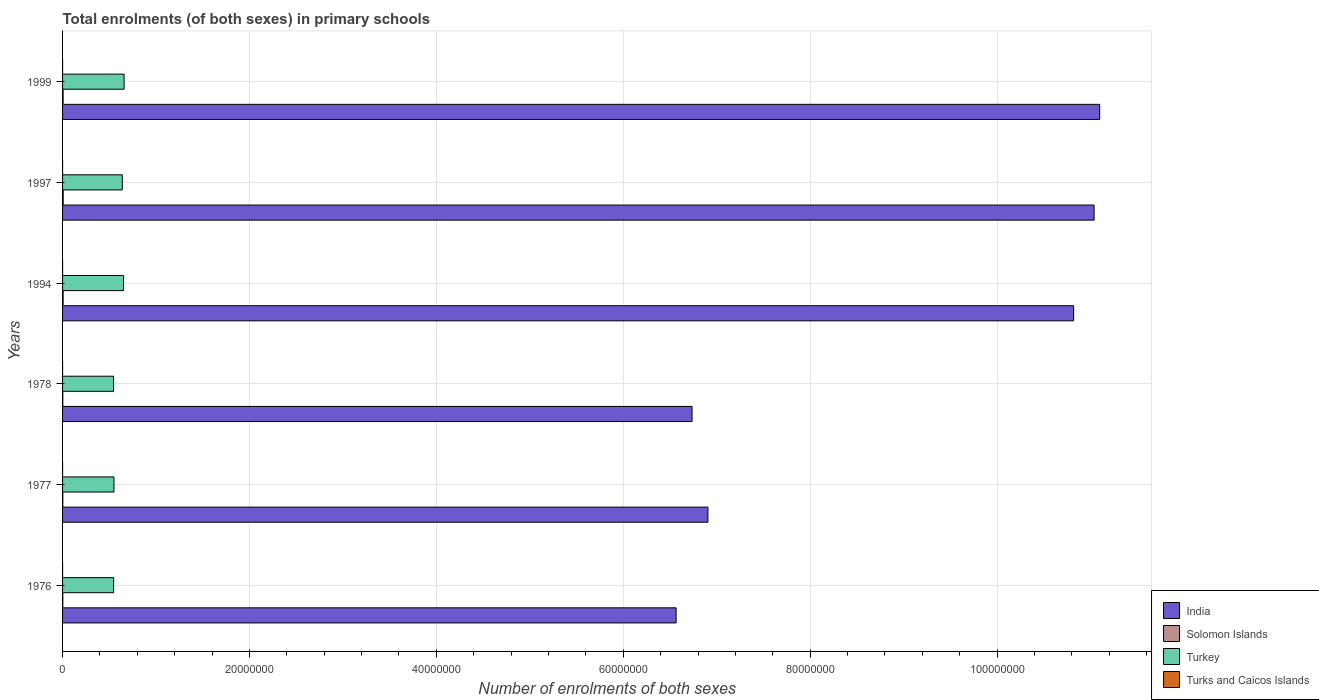How many groups of bars are there?
Offer a terse response. 6. Are the number of bars per tick equal to the number of legend labels?
Your answer should be very brief. Yes. What is the label of the 3rd group of bars from the top?
Your answer should be compact. 1994. In how many cases, is the number of bars for a given year not equal to the number of legend labels?
Provide a short and direct response. 0. What is the number of enrolments in primary schools in Turkey in 1999?
Offer a very short reply. 6.58e+06. Across all years, what is the maximum number of enrolments in primary schools in India?
Offer a terse response. 1.11e+08. Across all years, what is the minimum number of enrolments in primary schools in Turks and Caicos Islands?
Your answer should be very brief. 1573. In which year was the number of enrolments in primary schools in Turks and Caicos Islands minimum?
Provide a short and direct response. 1997. What is the total number of enrolments in primary schools in Turkey in the graph?
Ensure brevity in your answer.  3.59e+07. What is the difference between the number of enrolments in primary schools in Turks and Caicos Islands in 1978 and that in 1997?
Ensure brevity in your answer.  119. What is the difference between the number of enrolments in primary schools in Turkey in 1977 and the number of enrolments in primary schools in Solomon Islands in 1999?
Offer a terse response. 5.44e+06. What is the average number of enrolments in primary schools in Turks and Caicos Islands per year?
Provide a short and direct response. 1733.5. In the year 1978, what is the difference between the number of enrolments in primary schools in Turkey and number of enrolments in primary schools in Solomon Islands?
Give a very brief answer. 5.43e+06. What is the ratio of the number of enrolments in primary schools in Turks and Caicos Islands in 1976 to that in 1999?
Offer a terse response. 0.97. Is the number of enrolments in primary schools in Turks and Caicos Islands in 1994 less than that in 1997?
Offer a terse response. No. Is the difference between the number of enrolments in primary schools in Turkey in 1976 and 1977 greater than the difference between the number of enrolments in primary schools in Solomon Islands in 1976 and 1977?
Provide a short and direct response. No. What is the difference between the highest and the second highest number of enrolments in primary schools in Turks and Caicos Islands?
Offer a very short reply. 22. What is the difference between the highest and the lowest number of enrolments in primary schools in Solomon Islands?
Your answer should be compact. 4.04e+04. In how many years, is the number of enrolments in primary schools in Turkey greater than the average number of enrolments in primary schools in Turkey taken over all years?
Make the answer very short. 3. What does the 1st bar from the top in 1997 represents?
Keep it short and to the point. Turks and Caicos Islands. Is it the case that in every year, the sum of the number of enrolments in primary schools in Turkey and number of enrolments in primary schools in India is greater than the number of enrolments in primary schools in Solomon Islands?
Offer a terse response. Yes. How many bars are there?
Your answer should be compact. 24. Are all the bars in the graph horizontal?
Your answer should be compact. Yes. What is the title of the graph?
Give a very brief answer. Total enrolments (of both sexes) in primary schools. What is the label or title of the X-axis?
Your response must be concise. Number of enrolments of both sexes. What is the label or title of the Y-axis?
Ensure brevity in your answer.  Years. What is the Number of enrolments of both sexes of India in 1976?
Your response must be concise. 6.57e+07. What is the Number of enrolments of both sexes of Solomon Islands in 1976?
Offer a terse response. 2.70e+04. What is the Number of enrolments of both sexes in Turkey in 1976?
Make the answer very short. 5.46e+06. What is the Number of enrolments of both sexes in Turks and Caicos Islands in 1976?
Your response must be concise. 1764. What is the Number of enrolments of both sexes in India in 1977?
Offer a very short reply. 6.91e+07. What is the Number of enrolments of both sexes in Solomon Islands in 1977?
Your response must be concise. 2.64e+04. What is the Number of enrolments of both sexes in Turkey in 1977?
Keep it short and to the point. 5.50e+06. What is the Number of enrolments of both sexes in Turks and Caicos Islands in 1977?
Offer a terse response. 1800. What is the Number of enrolments of both sexes in India in 1978?
Make the answer very short. 6.74e+07. What is the Number of enrolments of both sexes in Solomon Islands in 1978?
Offer a terse response. 2.67e+04. What is the Number of enrolments of both sexes in Turkey in 1978?
Offer a very short reply. 5.45e+06. What is the Number of enrolments of both sexes of Turks and Caicos Islands in 1978?
Keep it short and to the point. 1692. What is the Number of enrolments of both sexes of India in 1994?
Give a very brief answer. 1.08e+08. What is the Number of enrolments of both sexes of Solomon Islands in 1994?
Your answer should be compact. 6.05e+04. What is the Number of enrolments of both sexes in Turkey in 1994?
Your answer should be very brief. 6.53e+06. What is the Number of enrolments of both sexes in Turks and Caicos Islands in 1994?
Give a very brief answer. 1750. What is the Number of enrolments of both sexes of India in 1997?
Make the answer very short. 1.10e+08. What is the Number of enrolments of both sexes of Solomon Islands in 1997?
Give a very brief answer. 6.68e+04. What is the Number of enrolments of both sexes of Turkey in 1997?
Provide a short and direct response. 6.39e+06. What is the Number of enrolments of both sexes of Turks and Caicos Islands in 1997?
Offer a terse response. 1573. What is the Number of enrolments of both sexes in India in 1999?
Ensure brevity in your answer.  1.11e+08. What is the Number of enrolments of both sexes in Solomon Islands in 1999?
Offer a terse response. 5.80e+04. What is the Number of enrolments of both sexes of Turkey in 1999?
Provide a short and direct response. 6.58e+06. What is the Number of enrolments of both sexes of Turks and Caicos Islands in 1999?
Ensure brevity in your answer.  1822. Across all years, what is the maximum Number of enrolments of both sexes of India?
Provide a short and direct response. 1.11e+08. Across all years, what is the maximum Number of enrolments of both sexes of Solomon Islands?
Your answer should be very brief. 6.68e+04. Across all years, what is the maximum Number of enrolments of both sexes of Turkey?
Keep it short and to the point. 6.58e+06. Across all years, what is the maximum Number of enrolments of both sexes in Turks and Caicos Islands?
Give a very brief answer. 1822. Across all years, what is the minimum Number of enrolments of both sexes in India?
Your answer should be compact. 6.57e+07. Across all years, what is the minimum Number of enrolments of both sexes of Solomon Islands?
Provide a short and direct response. 2.64e+04. Across all years, what is the minimum Number of enrolments of both sexes in Turkey?
Provide a short and direct response. 5.45e+06. Across all years, what is the minimum Number of enrolments of both sexes of Turks and Caicos Islands?
Keep it short and to the point. 1573. What is the total Number of enrolments of both sexes in India in the graph?
Provide a succinct answer. 5.32e+08. What is the total Number of enrolments of both sexes in Solomon Islands in the graph?
Your response must be concise. 2.66e+05. What is the total Number of enrolments of both sexes in Turkey in the graph?
Your response must be concise. 3.59e+07. What is the total Number of enrolments of both sexes in Turks and Caicos Islands in the graph?
Give a very brief answer. 1.04e+04. What is the difference between the Number of enrolments of both sexes in India in 1976 and that in 1977?
Provide a succinct answer. -3.40e+06. What is the difference between the Number of enrolments of both sexes of Solomon Islands in 1976 and that in 1977?
Offer a terse response. 631. What is the difference between the Number of enrolments of both sexes of Turkey in 1976 and that in 1977?
Ensure brevity in your answer.  -3.58e+04. What is the difference between the Number of enrolments of both sexes in Turks and Caicos Islands in 1976 and that in 1977?
Make the answer very short. -36. What is the difference between the Number of enrolments of both sexes of India in 1976 and that in 1978?
Make the answer very short. -1.70e+06. What is the difference between the Number of enrolments of both sexes in Solomon Islands in 1976 and that in 1978?
Give a very brief answer. 272. What is the difference between the Number of enrolments of both sexes in Turkey in 1976 and that in 1978?
Make the answer very short. 9328. What is the difference between the Number of enrolments of both sexes of Turks and Caicos Islands in 1976 and that in 1978?
Offer a terse response. 72. What is the difference between the Number of enrolments of both sexes in India in 1976 and that in 1994?
Keep it short and to the point. -4.25e+07. What is the difference between the Number of enrolments of both sexes in Solomon Islands in 1976 and that in 1994?
Make the answer very short. -3.35e+04. What is the difference between the Number of enrolments of both sexes in Turkey in 1976 and that in 1994?
Offer a very short reply. -1.06e+06. What is the difference between the Number of enrolments of both sexes in Turks and Caicos Islands in 1976 and that in 1994?
Your answer should be very brief. 14. What is the difference between the Number of enrolments of both sexes in India in 1976 and that in 1997?
Offer a very short reply. -4.47e+07. What is the difference between the Number of enrolments of both sexes of Solomon Islands in 1976 and that in 1997?
Your answer should be compact. -3.98e+04. What is the difference between the Number of enrolments of both sexes in Turkey in 1976 and that in 1997?
Make the answer very short. -9.25e+05. What is the difference between the Number of enrolments of both sexes of Turks and Caicos Islands in 1976 and that in 1997?
Your response must be concise. 191. What is the difference between the Number of enrolments of both sexes of India in 1976 and that in 1999?
Give a very brief answer. -4.53e+07. What is the difference between the Number of enrolments of both sexes of Solomon Islands in 1976 and that in 1999?
Your answer should be very brief. -3.10e+04. What is the difference between the Number of enrolments of both sexes in Turkey in 1976 and that in 1999?
Keep it short and to the point. -1.12e+06. What is the difference between the Number of enrolments of both sexes of Turks and Caicos Islands in 1976 and that in 1999?
Provide a succinct answer. -58. What is the difference between the Number of enrolments of both sexes in India in 1977 and that in 1978?
Your response must be concise. 1.70e+06. What is the difference between the Number of enrolments of both sexes of Solomon Islands in 1977 and that in 1978?
Provide a succinct answer. -359. What is the difference between the Number of enrolments of both sexes in Turkey in 1977 and that in 1978?
Your answer should be very brief. 4.51e+04. What is the difference between the Number of enrolments of both sexes in Turks and Caicos Islands in 1977 and that in 1978?
Make the answer very short. 108. What is the difference between the Number of enrolments of both sexes of India in 1977 and that in 1994?
Offer a terse response. -3.91e+07. What is the difference between the Number of enrolments of both sexes in Solomon Islands in 1977 and that in 1994?
Give a very brief answer. -3.41e+04. What is the difference between the Number of enrolments of both sexes of Turkey in 1977 and that in 1994?
Your answer should be compact. -1.03e+06. What is the difference between the Number of enrolments of both sexes of Turks and Caicos Islands in 1977 and that in 1994?
Provide a short and direct response. 50. What is the difference between the Number of enrolments of both sexes in India in 1977 and that in 1997?
Keep it short and to the point. -4.13e+07. What is the difference between the Number of enrolments of both sexes in Solomon Islands in 1977 and that in 1997?
Offer a terse response. -4.04e+04. What is the difference between the Number of enrolments of both sexes in Turkey in 1977 and that in 1997?
Keep it short and to the point. -8.90e+05. What is the difference between the Number of enrolments of both sexes of Turks and Caicos Islands in 1977 and that in 1997?
Give a very brief answer. 227. What is the difference between the Number of enrolments of both sexes in India in 1977 and that in 1999?
Keep it short and to the point. -4.19e+07. What is the difference between the Number of enrolments of both sexes of Solomon Islands in 1977 and that in 1999?
Offer a terse response. -3.16e+04. What is the difference between the Number of enrolments of both sexes in Turkey in 1977 and that in 1999?
Your answer should be compact. -1.08e+06. What is the difference between the Number of enrolments of both sexes in India in 1978 and that in 1994?
Keep it short and to the point. -4.08e+07. What is the difference between the Number of enrolments of both sexes in Solomon Islands in 1978 and that in 1994?
Your answer should be compact. -3.37e+04. What is the difference between the Number of enrolments of both sexes in Turkey in 1978 and that in 1994?
Ensure brevity in your answer.  -1.07e+06. What is the difference between the Number of enrolments of both sexes of Turks and Caicos Islands in 1978 and that in 1994?
Offer a terse response. -58. What is the difference between the Number of enrolments of both sexes in India in 1978 and that in 1997?
Provide a succinct answer. -4.30e+07. What is the difference between the Number of enrolments of both sexes in Solomon Islands in 1978 and that in 1997?
Provide a short and direct response. -4.01e+04. What is the difference between the Number of enrolments of both sexes of Turkey in 1978 and that in 1997?
Your answer should be very brief. -9.35e+05. What is the difference between the Number of enrolments of both sexes of Turks and Caicos Islands in 1978 and that in 1997?
Give a very brief answer. 119. What is the difference between the Number of enrolments of both sexes in India in 1978 and that in 1999?
Your response must be concise. -4.36e+07. What is the difference between the Number of enrolments of both sexes in Solomon Islands in 1978 and that in 1999?
Provide a short and direct response. -3.13e+04. What is the difference between the Number of enrolments of both sexes of Turkey in 1978 and that in 1999?
Offer a terse response. -1.13e+06. What is the difference between the Number of enrolments of both sexes of Turks and Caicos Islands in 1978 and that in 1999?
Make the answer very short. -130. What is the difference between the Number of enrolments of both sexes in India in 1994 and that in 1997?
Ensure brevity in your answer.  -2.19e+06. What is the difference between the Number of enrolments of both sexes of Solomon Islands in 1994 and that in 1997?
Offer a terse response. -6347. What is the difference between the Number of enrolments of both sexes in Turkey in 1994 and that in 1997?
Ensure brevity in your answer.  1.37e+05. What is the difference between the Number of enrolments of both sexes of Turks and Caicos Islands in 1994 and that in 1997?
Ensure brevity in your answer.  177. What is the difference between the Number of enrolments of both sexes in India in 1994 and that in 1999?
Provide a succinct answer. -2.79e+06. What is the difference between the Number of enrolments of both sexes in Solomon Islands in 1994 and that in 1999?
Your response must be concise. 2477. What is the difference between the Number of enrolments of both sexes in Turkey in 1994 and that in 1999?
Your answer should be compact. -5.69e+04. What is the difference between the Number of enrolments of both sexes in Turks and Caicos Islands in 1994 and that in 1999?
Make the answer very short. -72. What is the difference between the Number of enrolments of both sexes of India in 1997 and that in 1999?
Ensure brevity in your answer.  -5.95e+05. What is the difference between the Number of enrolments of both sexes in Solomon Islands in 1997 and that in 1999?
Offer a terse response. 8824. What is the difference between the Number of enrolments of both sexes of Turkey in 1997 and that in 1999?
Provide a succinct answer. -1.94e+05. What is the difference between the Number of enrolments of both sexes of Turks and Caicos Islands in 1997 and that in 1999?
Ensure brevity in your answer.  -249. What is the difference between the Number of enrolments of both sexes of India in 1976 and the Number of enrolments of both sexes of Solomon Islands in 1977?
Give a very brief answer. 6.56e+07. What is the difference between the Number of enrolments of both sexes in India in 1976 and the Number of enrolments of both sexes in Turkey in 1977?
Your response must be concise. 6.02e+07. What is the difference between the Number of enrolments of both sexes of India in 1976 and the Number of enrolments of both sexes of Turks and Caicos Islands in 1977?
Provide a short and direct response. 6.57e+07. What is the difference between the Number of enrolments of both sexes in Solomon Islands in 1976 and the Number of enrolments of both sexes in Turkey in 1977?
Your response must be concise. -5.47e+06. What is the difference between the Number of enrolments of both sexes in Solomon Islands in 1976 and the Number of enrolments of both sexes in Turks and Caicos Islands in 1977?
Keep it short and to the point. 2.52e+04. What is the difference between the Number of enrolments of both sexes in Turkey in 1976 and the Number of enrolments of both sexes in Turks and Caicos Islands in 1977?
Your response must be concise. 5.46e+06. What is the difference between the Number of enrolments of both sexes in India in 1976 and the Number of enrolments of both sexes in Solomon Islands in 1978?
Offer a very short reply. 6.56e+07. What is the difference between the Number of enrolments of both sexes in India in 1976 and the Number of enrolments of both sexes in Turkey in 1978?
Give a very brief answer. 6.02e+07. What is the difference between the Number of enrolments of both sexes in India in 1976 and the Number of enrolments of both sexes in Turks and Caicos Islands in 1978?
Provide a succinct answer. 6.57e+07. What is the difference between the Number of enrolments of both sexes of Solomon Islands in 1976 and the Number of enrolments of both sexes of Turkey in 1978?
Offer a terse response. -5.43e+06. What is the difference between the Number of enrolments of both sexes of Solomon Islands in 1976 and the Number of enrolments of both sexes of Turks and Caicos Islands in 1978?
Provide a succinct answer. 2.53e+04. What is the difference between the Number of enrolments of both sexes in Turkey in 1976 and the Number of enrolments of both sexes in Turks and Caicos Islands in 1978?
Your answer should be compact. 5.46e+06. What is the difference between the Number of enrolments of both sexes of India in 1976 and the Number of enrolments of both sexes of Solomon Islands in 1994?
Your response must be concise. 6.56e+07. What is the difference between the Number of enrolments of both sexes in India in 1976 and the Number of enrolments of both sexes in Turkey in 1994?
Offer a very short reply. 5.91e+07. What is the difference between the Number of enrolments of both sexes of India in 1976 and the Number of enrolments of both sexes of Turks and Caicos Islands in 1994?
Offer a terse response. 6.57e+07. What is the difference between the Number of enrolments of both sexes in Solomon Islands in 1976 and the Number of enrolments of both sexes in Turkey in 1994?
Keep it short and to the point. -6.50e+06. What is the difference between the Number of enrolments of both sexes of Solomon Islands in 1976 and the Number of enrolments of both sexes of Turks and Caicos Islands in 1994?
Make the answer very short. 2.53e+04. What is the difference between the Number of enrolments of both sexes of Turkey in 1976 and the Number of enrolments of both sexes of Turks and Caicos Islands in 1994?
Your response must be concise. 5.46e+06. What is the difference between the Number of enrolments of both sexes in India in 1976 and the Number of enrolments of both sexes in Solomon Islands in 1997?
Offer a terse response. 6.56e+07. What is the difference between the Number of enrolments of both sexes in India in 1976 and the Number of enrolments of both sexes in Turkey in 1997?
Provide a succinct answer. 5.93e+07. What is the difference between the Number of enrolments of both sexes in India in 1976 and the Number of enrolments of both sexes in Turks and Caicos Islands in 1997?
Give a very brief answer. 6.57e+07. What is the difference between the Number of enrolments of both sexes of Solomon Islands in 1976 and the Number of enrolments of both sexes of Turkey in 1997?
Your answer should be very brief. -6.36e+06. What is the difference between the Number of enrolments of both sexes of Solomon Islands in 1976 and the Number of enrolments of both sexes of Turks and Caicos Islands in 1997?
Give a very brief answer. 2.54e+04. What is the difference between the Number of enrolments of both sexes in Turkey in 1976 and the Number of enrolments of both sexes in Turks and Caicos Islands in 1997?
Your response must be concise. 5.46e+06. What is the difference between the Number of enrolments of both sexes of India in 1976 and the Number of enrolments of both sexes of Solomon Islands in 1999?
Keep it short and to the point. 6.56e+07. What is the difference between the Number of enrolments of both sexes in India in 1976 and the Number of enrolments of both sexes in Turkey in 1999?
Your answer should be compact. 5.91e+07. What is the difference between the Number of enrolments of both sexes in India in 1976 and the Number of enrolments of both sexes in Turks and Caicos Islands in 1999?
Provide a short and direct response. 6.57e+07. What is the difference between the Number of enrolments of both sexes in Solomon Islands in 1976 and the Number of enrolments of both sexes in Turkey in 1999?
Give a very brief answer. -6.56e+06. What is the difference between the Number of enrolments of both sexes in Solomon Islands in 1976 and the Number of enrolments of both sexes in Turks and Caicos Islands in 1999?
Provide a succinct answer. 2.52e+04. What is the difference between the Number of enrolments of both sexes in Turkey in 1976 and the Number of enrolments of both sexes in Turks and Caicos Islands in 1999?
Keep it short and to the point. 5.46e+06. What is the difference between the Number of enrolments of both sexes in India in 1977 and the Number of enrolments of both sexes in Solomon Islands in 1978?
Make the answer very short. 6.90e+07. What is the difference between the Number of enrolments of both sexes of India in 1977 and the Number of enrolments of both sexes of Turkey in 1978?
Your response must be concise. 6.36e+07. What is the difference between the Number of enrolments of both sexes in India in 1977 and the Number of enrolments of both sexes in Turks and Caicos Islands in 1978?
Your response must be concise. 6.91e+07. What is the difference between the Number of enrolments of both sexes in Solomon Islands in 1977 and the Number of enrolments of both sexes in Turkey in 1978?
Your answer should be very brief. -5.43e+06. What is the difference between the Number of enrolments of both sexes of Solomon Islands in 1977 and the Number of enrolments of both sexes of Turks and Caicos Islands in 1978?
Your answer should be very brief. 2.47e+04. What is the difference between the Number of enrolments of both sexes of Turkey in 1977 and the Number of enrolments of both sexes of Turks and Caicos Islands in 1978?
Give a very brief answer. 5.50e+06. What is the difference between the Number of enrolments of both sexes of India in 1977 and the Number of enrolments of both sexes of Solomon Islands in 1994?
Your response must be concise. 6.90e+07. What is the difference between the Number of enrolments of both sexes of India in 1977 and the Number of enrolments of both sexes of Turkey in 1994?
Your answer should be compact. 6.25e+07. What is the difference between the Number of enrolments of both sexes of India in 1977 and the Number of enrolments of both sexes of Turks and Caicos Islands in 1994?
Keep it short and to the point. 6.91e+07. What is the difference between the Number of enrolments of both sexes of Solomon Islands in 1977 and the Number of enrolments of both sexes of Turkey in 1994?
Your answer should be compact. -6.50e+06. What is the difference between the Number of enrolments of both sexes of Solomon Islands in 1977 and the Number of enrolments of both sexes of Turks and Caicos Islands in 1994?
Provide a short and direct response. 2.46e+04. What is the difference between the Number of enrolments of both sexes of Turkey in 1977 and the Number of enrolments of both sexes of Turks and Caicos Islands in 1994?
Offer a very short reply. 5.50e+06. What is the difference between the Number of enrolments of both sexes in India in 1977 and the Number of enrolments of both sexes in Solomon Islands in 1997?
Provide a succinct answer. 6.90e+07. What is the difference between the Number of enrolments of both sexes of India in 1977 and the Number of enrolments of both sexes of Turkey in 1997?
Offer a terse response. 6.27e+07. What is the difference between the Number of enrolments of both sexes in India in 1977 and the Number of enrolments of both sexes in Turks and Caicos Islands in 1997?
Provide a succinct answer. 6.91e+07. What is the difference between the Number of enrolments of both sexes of Solomon Islands in 1977 and the Number of enrolments of both sexes of Turkey in 1997?
Your answer should be very brief. -6.36e+06. What is the difference between the Number of enrolments of both sexes in Solomon Islands in 1977 and the Number of enrolments of both sexes in Turks and Caicos Islands in 1997?
Provide a short and direct response. 2.48e+04. What is the difference between the Number of enrolments of both sexes in Turkey in 1977 and the Number of enrolments of both sexes in Turks and Caicos Islands in 1997?
Keep it short and to the point. 5.50e+06. What is the difference between the Number of enrolments of both sexes of India in 1977 and the Number of enrolments of both sexes of Solomon Islands in 1999?
Your answer should be compact. 6.90e+07. What is the difference between the Number of enrolments of both sexes of India in 1977 and the Number of enrolments of both sexes of Turkey in 1999?
Ensure brevity in your answer.  6.25e+07. What is the difference between the Number of enrolments of both sexes in India in 1977 and the Number of enrolments of both sexes in Turks and Caicos Islands in 1999?
Make the answer very short. 6.91e+07. What is the difference between the Number of enrolments of both sexes in Solomon Islands in 1977 and the Number of enrolments of both sexes in Turkey in 1999?
Ensure brevity in your answer.  -6.56e+06. What is the difference between the Number of enrolments of both sexes of Solomon Islands in 1977 and the Number of enrolments of both sexes of Turks and Caicos Islands in 1999?
Provide a succinct answer. 2.46e+04. What is the difference between the Number of enrolments of both sexes of Turkey in 1977 and the Number of enrolments of both sexes of Turks and Caicos Islands in 1999?
Keep it short and to the point. 5.50e+06. What is the difference between the Number of enrolments of both sexes of India in 1978 and the Number of enrolments of both sexes of Solomon Islands in 1994?
Your answer should be very brief. 6.73e+07. What is the difference between the Number of enrolments of both sexes of India in 1978 and the Number of enrolments of both sexes of Turkey in 1994?
Your answer should be compact. 6.08e+07. What is the difference between the Number of enrolments of both sexes in India in 1978 and the Number of enrolments of both sexes in Turks and Caicos Islands in 1994?
Provide a succinct answer. 6.74e+07. What is the difference between the Number of enrolments of both sexes in Solomon Islands in 1978 and the Number of enrolments of both sexes in Turkey in 1994?
Offer a very short reply. -6.50e+06. What is the difference between the Number of enrolments of both sexes in Solomon Islands in 1978 and the Number of enrolments of both sexes in Turks and Caicos Islands in 1994?
Provide a short and direct response. 2.50e+04. What is the difference between the Number of enrolments of both sexes in Turkey in 1978 and the Number of enrolments of both sexes in Turks and Caicos Islands in 1994?
Offer a terse response. 5.45e+06. What is the difference between the Number of enrolments of both sexes of India in 1978 and the Number of enrolments of both sexes of Solomon Islands in 1997?
Your answer should be compact. 6.73e+07. What is the difference between the Number of enrolments of both sexes in India in 1978 and the Number of enrolments of both sexes in Turkey in 1997?
Ensure brevity in your answer.  6.10e+07. What is the difference between the Number of enrolments of both sexes in India in 1978 and the Number of enrolments of both sexes in Turks and Caicos Islands in 1997?
Your answer should be compact. 6.74e+07. What is the difference between the Number of enrolments of both sexes in Solomon Islands in 1978 and the Number of enrolments of both sexes in Turkey in 1997?
Make the answer very short. -6.36e+06. What is the difference between the Number of enrolments of both sexes of Solomon Islands in 1978 and the Number of enrolments of both sexes of Turks and Caicos Islands in 1997?
Your answer should be compact. 2.52e+04. What is the difference between the Number of enrolments of both sexes in Turkey in 1978 and the Number of enrolments of both sexes in Turks and Caicos Islands in 1997?
Give a very brief answer. 5.45e+06. What is the difference between the Number of enrolments of both sexes of India in 1978 and the Number of enrolments of both sexes of Solomon Islands in 1999?
Offer a terse response. 6.73e+07. What is the difference between the Number of enrolments of both sexes of India in 1978 and the Number of enrolments of both sexes of Turkey in 1999?
Make the answer very short. 6.08e+07. What is the difference between the Number of enrolments of both sexes of India in 1978 and the Number of enrolments of both sexes of Turks and Caicos Islands in 1999?
Your answer should be very brief. 6.74e+07. What is the difference between the Number of enrolments of both sexes in Solomon Islands in 1978 and the Number of enrolments of both sexes in Turkey in 1999?
Give a very brief answer. -6.56e+06. What is the difference between the Number of enrolments of both sexes in Solomon Islands in 1978 and the Number of enrolments of both sexes in Turks and Caicos Islands in 1999?
Your answer should be very brief. 2.49e+04. What is the difference between the Number of enrolments of both sexes of Turkey in 1978 and the Number of enrolments of both sexes of Turks and Caicos Islands in 1999?
Your response must be concise. 5.45e+06. What is the difference between the Number of enrolments of both sexes of India in 1994 and the Number of enrolments of both sexes of Solomon Islands in 1997?
Offer a very short reply. 1.08e+08. What is the difference between the Number of enrolments of both sexes of India in 1994 and the Number of enrolments of both sexes of Turkey in 1997?
Provide a succinct answer. 1.02e+08. What is the difference between the Number of enrolments of both sexes of India in 1994 and the Number of enrolments of both sexes of Turks and Caicos Islands in 1997?
Make the answer very short. 1.08e+08. What is the difference between the Number of enrolments of both sexes in Solomon Islands in 1994 and the Number of enrolments of both sexes in Turkey in 1997?
Your answer should be compact. -6.33e+06. What is the difference between the Number of enrolments of both sexes of Solomon Islands in 1994 and the Number of enrolments of both sexes of Turks and Caicos Islands in 1997?
Give a very brief answer. 5.89e+04. What is the difference between the Number of enrolments of both sexes of Turkey in 1994 and the Number of enrolments of both sexes of Turks and Caicos Islands in 1997?
Offer a very short reply. 6.52e+06. What is the difference between the Number of enrolments of both sexes of India in 1994 and the Number of enrolments of both sexes of Solomon Islands in 1999?
Your response must be concise. 1.08e+08. What is the difference between the Number of enrolments of both sexes of India in 1994 and the Number of enrolments of both sexes of Turkey in 1999?
Offer a very short reply. 1.02e+08. What is the difference between the Number of enrolments of both sexes of India in 1994 and the Number of enrolments of both sexes of Turks and Caicos Islands in 1999?
Your answer should be compact. 1.08e+08. What is the difference between the Number of enrolments of both sexes in Solomon Islands in 1994 and the Number of enrolments of both sexes in Turkey in 1999?
Your answer should be compact. -6.52e+06. What is the difference between the Number of enrolments of both sexes of Solomon Islands in 1994 and the Number of enrolments of both sexes of Turks and Caicos Islands in 1999?
Your response must be concise. 5.87e+04. What is the difference between the Number of enrolments of both sexes of Turkey in 1994 and the Number of enrolments of both sexes of Turks and Caicos Islands in 1999?
Your answer should be very brief. 6.52e+06. What is the difference between the Number of enrolments of both sexes in India in 1997 and the Number of enrolments of both sexes in Solomon Islands in 1999?
Your response must be concise. 1.10e+08. What is the difference between the Number of enrolments of both sexes in India in 1997 and the Number of enrolments of both sexes in Turkey in 1999?
Provide a short and direct response. 1.04e+08. What is the difference between the Number of enrolments of both sexes in India in 1997 and the Number of enrolments of both sexes in Turks and Caicos Islands in 1999?
Your answer should be very brief. 1.10e+08. What is the difference between the Number of enrolments of both sexes of Solomon Islands in 1997 and the Number of enrolments of both sexes of Turkey in 1999?
Make the answer very short. -6.52e+06. What is the difference between the Number of enrolments of both sexes in Solomon Islands in 1997 and the Number of enrolments of both sexes in Turks and Caicos Islands in 1999?
Ensure brevity in your answer.  6.50e+04. What is the difference between the Number of enrolments of both sexes of Turkey in 1997 and the Number of enrolments of both sexes of Turks and Caicos Islands in 1999?
Make the answer very short. 6.39e+06. What is the average Number of enrolments of both sexes of India per year?
Give a very brief answer. 8.86e+07. What is the average Number of enrolments of both sexes of Solomon Islands per year?
Provide a succinct answer. 4.43e+04. What is the average Number of enrolments of both sexes of Turkey per year?
Make the answer very short. 5.99e+06. What is the average Number of enrolments of both sexes in Turks and Caicos Islands per year?
Offer a very short reply. 1733.5. In the year 1976, what is the difference between the Number of enrolments of both sexes of India and Number of enrolments of both sexes of Solomon Islands?
Your response must be concise. 6.56e+07. In the year 1976, what is the difference between the Number of enrolments of both sexes in India and Number of enrolments of both sexes in Turkey?
Your response must be concise. 6.02e+07. In the year 1976, what is the difference between the Number of enrolments of both sexes in India and Number of enrolments of both sexes in Turks and Caicos Islands?
Your answer should be compact. 6.57e+07. In the year 1976, what is the difference between the Number of enrolments of both sexes of Solomon Islands and Number of enrolments of both sexes of Turkey?
Make the answer very short. -5.44e+06. In the year 1976, what is the difference between the Number of enrolments of both sexes in Solomon Islands and Number of enrolments of both sexes in Turks and Caicos Islands?
Your response must be concise. 2.53e+04. In the year 1976, what is the difference between the Number of enrolments of both sexes of Turkey and Number of enrolments of both sexes of Turks and Caicos Islands?
Provide a short and direct response. 5.46e+06. In the year 1977, what is the difference between the Number of enrolments of both sexes in India and Number of enrolments of both sexes in Solomon Islands?
Provide a short and direct response. 6.90e+07. In the year 1977, what is the difference between the Number of enrolments of both sexes of India and Number of enrolments of both sexes of Turkey?
Ensure brevity in your answer.  6.36e+07. In the year 1977, what is the difference between the Number of enrolments of both sexes of India and Number of enrolments of both sexes of Turks and Caicos Islands?
Make the answer very short. 6.91e+07. In the year 1977, what is the difference between the Number of enrolments of both sexes in Solomon Islands and Number of enrolments of both sexes in Turkey?
Provide a short and direct response. -5.47e+06. In the year 1977, what is the difference between the Number of enrolments of both sexes in Solomon Islands and Number of enrolments of both sexes in Turks and Caicos Islands?
Keep it short and to the point. 2.46e+04. In the year 1977, what is the difference between the Number of enrolments of both sexes of Turkey and Number of enrolments of both sexes of Turks and Caicos Islands?
Give a very brief answer. 5.50e+06. In the year 1978, what is the difference between the Number of enrolments of both sexes of India and Number of enrolments of both sexes of Solomon Islands?
Provide a succinct answer. 6.73e+07. In the year 1978, what is the difference between the Number of enrolments of both sexes in India and Number of enrolments of both sexes in Turkey?
Offer a terse response. 6.19e+07. In the year 1978, what is the difference between the Number of enrolments of both sexes in India and Number of enrolments of both sexes in Turks and Caicos Islands?
Ensure brevity in your answer.  6.74e+07. In the year 1978, what is the difference between the Number of enrolments of both sexes of Solomon Islands and Number of enrolments of both sexes of Turkey?
Offer a terse response. -5.43e+06. In the year 1978, what is the difference between the Number of enrolments of both sexes of Solomon Islands and Number of enrolments of both sexes of Turks and Caicos Islands?
Offer a very short reply. 2.51e+04. In the year 1978, what is the difference between the Number of enrolments of both sexes in Turkey and Number of enrolments of both sexes in Turks and Caicos Islands?
Your answer should be very brief. 5.45e+06. In the year 1994, what is the difference between the Number of enrolments of both sexes in India and Number of enrolments of both sexes in Solomon Islands?
Keep it short and to the point. 1.08e+08. In the year 1994, what is the difference between the Number of enrolments of both sexes in India and Number of enrolments of both sexes in Turkey?
Keep it short and to the point. 1.02e+08. In the year 1994, what is the difference between the Number of enrolments of both sexes in India and Number of enrolments of both sexes in Turks and Caicos Islands?
Keep it short and to the point. 1.08e+08. In the year 1994, what is the difference between the Number of enrolments of both sexes of Solomon Islands and Number of enrolments of both sexes of Turkey?
Your answer should be very brief. -6.47e+06. In the year 1994, what is the difference between the Number of enrolments of both sexes in Solomon Islands and Number of enrolments of both sexes in Turks and Caicos Islands?
Your answer should be very brief. 5.87e+04. In the year 1994, what is the difference between the Number of enrolments of both sexes in Turkey and Number of enrolments of both sexes in Turks and Caicos Islands?
Offer a very short reply. 6.52e+06. In the year 1997, what is the difference between the Number of enrolments of both sexes in India and Number of enrolments of both sexes in Solomon Islands?
Ensure brevity in your answer.  1.10e+08. In the year 1997, what is the difference between the Number of enrolments of both sexes in India and Number of enrolments of both sexes in Turkey?
Provide a short and direct response. 1.04e+08. In the year 1997, what is the difference between the Number of enrolments of both sexes in India and Number of enrolments of both sexes in Turks and Caicos Islands?
Your response must be concise. 1.10e+08. In the year 1997, what is the difference between the Number of enrolments of both sexes of Solomon Islands and Number of enrolments of both sexes of Turkey?
Offer a terse response. -6.32e+06. In the year 1997, what is the difference between the Number of enrolments of both sexes in Solomon Islands and Number of enrolments of both sexes in Turks and Caicos Islands?
Offer a terse response. 6.53e+04. In the year 1997, what is the difference between the Number of enrolments of both sexes of Turkey and Number of enrolments of both sexes of Turks and Caicos Islands?
Provide a succinct answer. 6.39e+06. In the year 1999, what is the difference between the Number of enrolments of both sexes in India and Number of enrolments of both sexes in Solomon Islands?
Give a very brief answer. 1.11e+08. In the year 1999, what is the difference between the Number of enrolments of both sexes in India and Number of enrolments of both sexes in Turkey?
Provide a succinct answer. 1.04e+08. In the year 1999, what is the difference between the Number of enrolments of both sexes in India and Number of enrolments of both sexes in Turks and Caicos Islands?
Make the answer very short. 1.11e+08. In the year 1999, what is the difference between the Number of enrolments of both sexes in Solomon Islands and Number of enrolments of both sexes in Turkey?
Provide a short and direct response. -6.53e+06. In the year 1999, what is the difference between the Number of enrolments of both sexes in Solomon Islands and Number of enrolments of both sexes in Turks and Caicos Islands?
Give a very brief answer. 5.62e+04. In the year 1999, what is the difference between the Number of enrolments of both sexes in Turkey and Number of enrolments of both sexes in Turks and Caicos Islands?
Provide a short and direct response. 6.58e+06. What is the ratio of the Number of enrolments of both sexes of India in 1976 to that in 1977?
Your answer should be very brief. 0.95. What is the ratio of the Number of enrolments of both sexes of Solomon Islands in 1976 to that in 1977?
Provide a short and direct response. 1.02. What is the ratio of the Number of enrolments of both sexes in India in 1976 to that in 1978?
Provide a succinct answer. 0.97. What is the ratio of the Number of enrolments of both sexes of Solomon Islands in 1976 to that in 1978?
Provide a succinct answer. 1.01. What is the ratio of the Number of enrolments of both sexes in Turks and Caicos Islands in 1976 to that in 1978?
Provide a short and direct response. 1.04. What is the ratio of the Number of enrolments of both sexes in India in 1976 to that in 1994?
Ensure brevity in your answer.  0.61. What is the ratio of the Number of enrolments of both sexes in Solomon Islands in 1976 to that in 1994?
Your response must be concise. 0.45. What is the ratio of the Number of enrolments of both sexes in Turkey in 1976 to that in 1994?
Give a very brief answer. 0.84. What is the ratio of the Number of enrolments of both sexes in India in 1976 to that in 1997?
Your response must be concise. 0.59. What is the ratio of the Number of enrolments of both sexes of Solomon Islands in 1976 to that in 1997?
Keep it short and to the point. 0.4. What is the ratio of the Number of enrolments of both sexes in Turkey in 1976 to that in 1997?
Your answer should be compact. 0.86. What is the ratio of the Number of enrolments of both sexes in Turks and Caicos Islands in 1976 to that in 1997?
Give a very brief answer. 1.12. What is the ratio of the Number of enrolments of both sexes of India in 1976 to that in 1999?
Your answer should be very brief. 0.59. What is the ratio of the Number of enrolments of both sexes in Solomon Islands in 1976 to that in 1999?
Offer a terse response. 0.47. What is the ratio of the Number of enrolments of both sexes of Turkey in 1976 to that in 1999?
Your answer should be compact. 0.83. What is the ratio of the Number of enrolments of both sexes in Turks and Caicos Islands in 1976 to that in 1999?
Make the answer very short. 0.97. What is the ratio of the Number of enrolments of both sexes in India in 1977 to that in 1978?
Your answer should be compact. 1.03. What is the ratio of the Number of enrolments of both sexes of Solomon Islands in 1977 to that in 1978?
Your answer should be compact. 0.99. What is the ratio of the Number of enrolments of both sexes of Turkey in 1977 to that in 1978?
Your answer should be compact. 1.01. What is the ratio of the Number of enrolments of both sexes of Turks and Caicos Islands in 1977 to that in 1978?
Your answer should be very brief. 1.06. What is the ratio of the Number of enrolments of both sexes in India in 1977 to that in 1994?
Provide a short and direct response. 0.64. What is the ratio of the Number of enrolments of both sexes of Solomon Islands in 1977 to that in 1994?
Ensure brevity in your answer.  0.44. What is the ratio of the Number of enrolments of both sexes of Turkey in 1977 to that in 1994?
Provide a succinct answer. 0.84. What is the ratio of the Number of enrolments of both sexes of Turks and Caicos Islands in 1977 to that in 1994?
Give a very brief answer. 1.03. What is the ratio of the Number of enrolments of both sexes of India in 1977 to that in 1997?
Provide a succinct answer. 0.63. What is the ratio of the Number of enrolments of both sexes in Solomon Islands in 1977 to that in 1997?
Your answer should be very brief. 0.39. What is the ratio of the Number of enrolments of both sexes in Turkey in 1977 to that in 1997?
Provide a succinct answer. 0.86. What is the ratio of the Number of enrolments of both sexes in Turks and Caicos Islands in 1977 to that in 1997?
Your response must be concise. 1.14. What is the ratio of the Number of enrolments of both sexes in India in 1977 to that in 1999?
Your answer should be very brief. 0.62. What is the ratio of the Number of enrolments of both sexes of Solomon Islands in 1977 to that in 1999?
Offer a terse response. 0.45. What is the ratio of the Number of enrolments of both sexes in Turkey in 1977 to that in 1999?
Keep it short and to the point. 0.84. What is the ratio of the Number of enrolments of both sexes in Turks and Caicos Islands in 1977 to that in 1999?
Offer a very short reply. 0.99. What is the ratio of the Number of enrolments of both sexes in India in 1978 to that in 1994?
Give a very brief answer. 0.62. What is the ratio of the Number of enrolments of both sexes of Solomon Islands in 1978 to that in 1994?
Offer a terse response. 0.44. What is the ratio of the Number of enrolments of both sexes of Turkey in 1978 to that in 1994?
Keep it short and to the point. 0.84. What is the ratio of the Number of enrolments of both sexes in Turks and Caicos Islands in 1978 to that in 1994?
Make the answer very short. 0.97. What is the ratio of the Number of enrolments of both sexes of India in 1978 to that in 1997?
Provide a short and direct response. 0.61. What is the ratio of the Number of enrolments of both sexes in Solomon Islands in 1978 to that in 1997?
Give a very brief answer. 0.4. What is the ratio of the Number of enrolments of both sexes in Turkey in 1978 to that in 1997?
Provide a short and direct response. 0.85. What is the ratio of the Number of enrolments of both sexes in Turks and Caicos Islands in 1978 to that in 1997?
Make the answer very short. 1.08. What is the ratio of the Number of enrolments of both sexes of India in 1978 to that in 1999?
Make the answer very short. 0.61. What is the ratio of the Number of enrolments of both sexes of Solomon Islands in 1978 to that in 1999?
Offer a terse response. 0.46. What is the ratio of the Number of enrolments of both sexes in Turkey in 1978 to that in 1999?
Keep it short and to the point. 0.83. What is the ratio of the Number of enrolments of both sexes in India in 1994 to that in 1997?
Keep it short and to the point. 0.98. What is the ratio of the Number of enrolments of both sexes in Solomon Islands in 1994 to that in 1997?
Keep it short and to the point. 0.91. What is the ratio of the Number of enrolments of both sexes of Turkey in 1994 to that in 1997?
Your answer should be compact. 1.02. What is the ratio of the Number of enrolments of both sexes of Turks and Caicos Islands in 1994 to that in 1997?
Give a very brief answer. 1.11. What is the ratio of the Number of enrolments of both sexes of India in 1994 to that in 1999?
Make the answer very short. 0.97. What is the ratio of the Number of enrolments of both sexes in Solomon Islands in 1994 to that in 1999?
Offer a terse response. 1.04. What is the ratio of the Number of enrolments of both sexes in Turkey in 1994 to that in 1999?
Keep it short and to the point. 0.99. What is the ratio of the Number of enrolments of both sexes in Turks and Caicos Islands in 1994 to that in 1999?
Keep it short and to the point. 0.96. What is the ratio of the Number of enrolments of both sexes of India in 1997 to that in 1999?
Provide a short and direct response. 0.99. What is the ratio of the Number of enrolments of both sexes of Solomon Islands in 1997 to that in 1999?
Provide a succinct answer. 1.15. What is the ratio of the Number of enrolments of both sexes in Turkey in 1997 to that in 1999?
Ensure brevity in your answer.  0.97. What is the ratio of the Number of enrolments of both sexes in Turks and Caicos Islands in 1997 to that in 1999?
Your answer should be very brief. 0.86. What is the difference between the highest and the second highest Number of enrolments of both sexes in India?
Offer a terse response. 5.95e+05. What is the difference between the highest and the second highest Number of enrolments of both sexes of Solomon Islands?
Your answer should be compact. 6347. What is the difference between the highest and the second highest Number of enrolments of both sexes in Turkey?
Your answer should be very brief. 5.69e+04. What is the difference between the highest and the second highest Number of enrolments of both sexes of Turks and Caicos Islands?
Offer a terse response. 22. What is the difference between the highest and the lowest Number of enrolments of both sexes of India?
Give a very brief answer. 4.53e+07. What is the difference between the highest and the lowest Number of enrolments of both sexes in Solomon Islands?
Give a very brief answer. 4.04e+04. What is the difference between the highest and the lowest Number of enrolments of both sexes in Turkey?
Your answer should be compact. 1.13e+06. What is the difference between the highest and the lowest Number of enrolments of both sexes in Turks and Caicos Islands?
Your answer should be very brief. 249. 